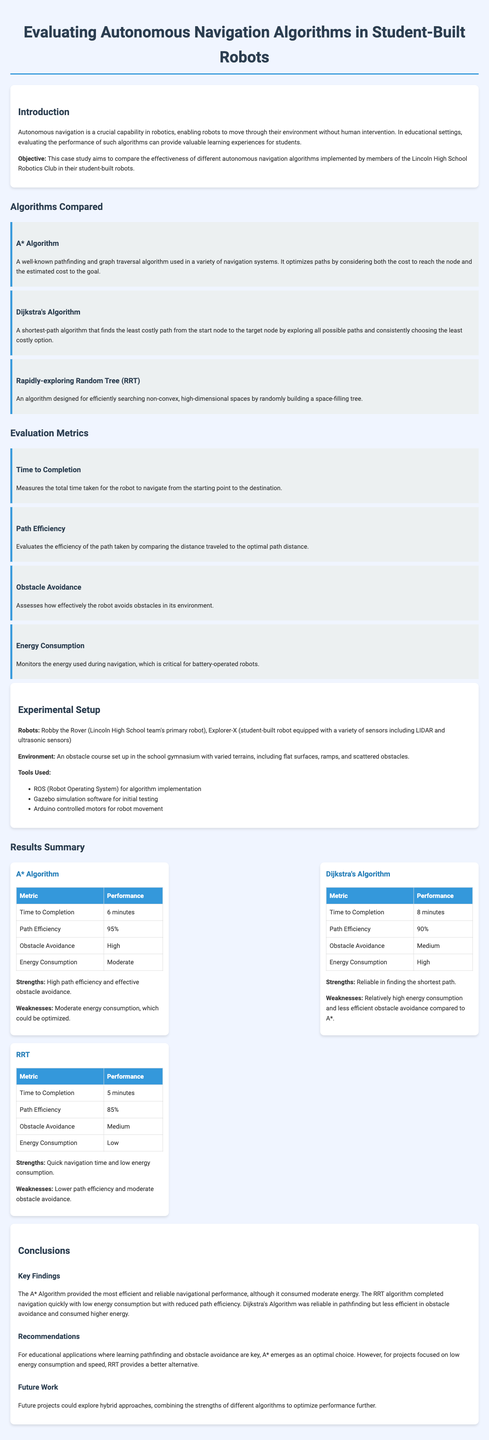What is the primary objective of the case study? The case study aims to compare the effectiveness of different autonomous navigation algorithms implemented by members of the Lincoln High School Robotics Club in their student-built robots.
Answer: Compare the effectiveness of different autonomous navigation algorithms Which algorithm had the highest path efficiency? The A* Algorithm reported the highest path efficiency at 95%.
Answer: A* Algorithm What was the time to completion for the RRT algorithm? The RRT algorithm completed navigation in 5 minutes.
Answer: 5 minutes What is one of the tools used for the algorithm implementation? The document mentions ROS (Robot Operating System) as a tool used for algorithm implementation.
Answer: ROS (Robot Operating System) Which algorithm is recommended for educational applications? The A* Algorithm is recommended for educational applications where learning pathfinding and obstacle avoidance are key.
Answer: A* Algorithm What metric assesses how effectively the robot avoids obstacles? The metric that assesses obstacle avoidance is called "Obstacle Avoidance."
Answer: Obstacle Avoidance What is one weakness of the Dijkstra's Algorithm? The document indicates that Dijkstra's Algorithm has relatively high energy consumption as a weakness.
Answer: High energy consumption Which robot was the primary robot of Lincoln High School's team? The primary robot of Lincoln High School's team is named Robby the Rover.
Answer: Robby the Rover How does RRT perform in terms of energy consumption? The RRT algorithm has low energy consumption according to the results summarized in the document.
Answer: Low 